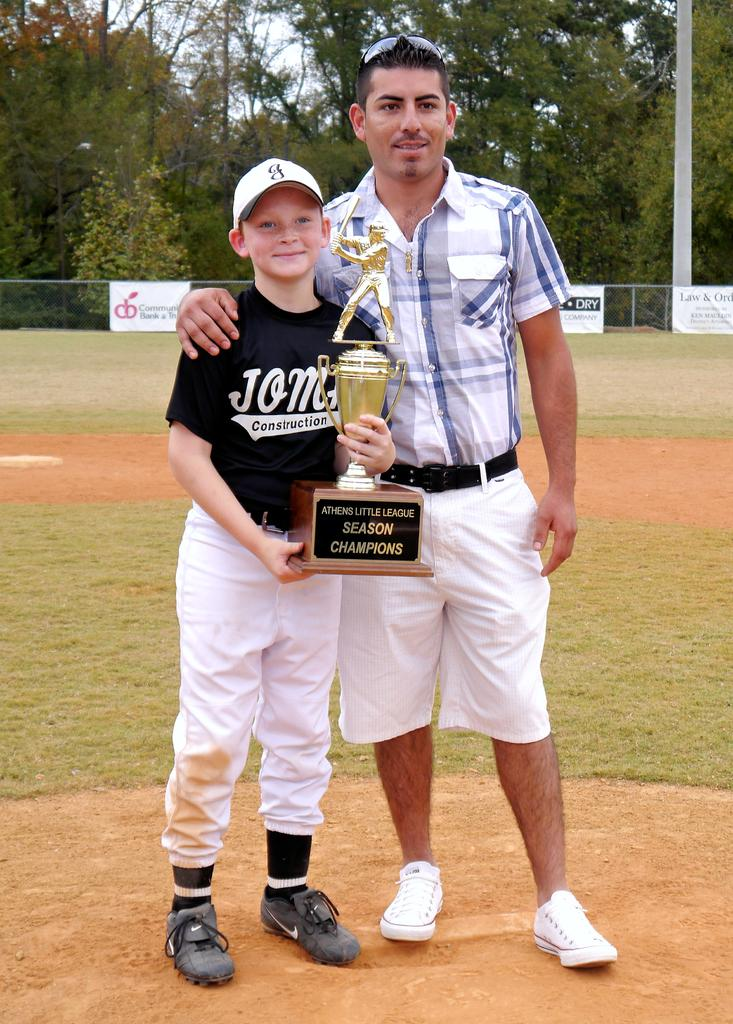<image>
Write a terse but informative summary of the picture. A father and son posing for a picture holding the Athens Little League Season Champions trophy. 